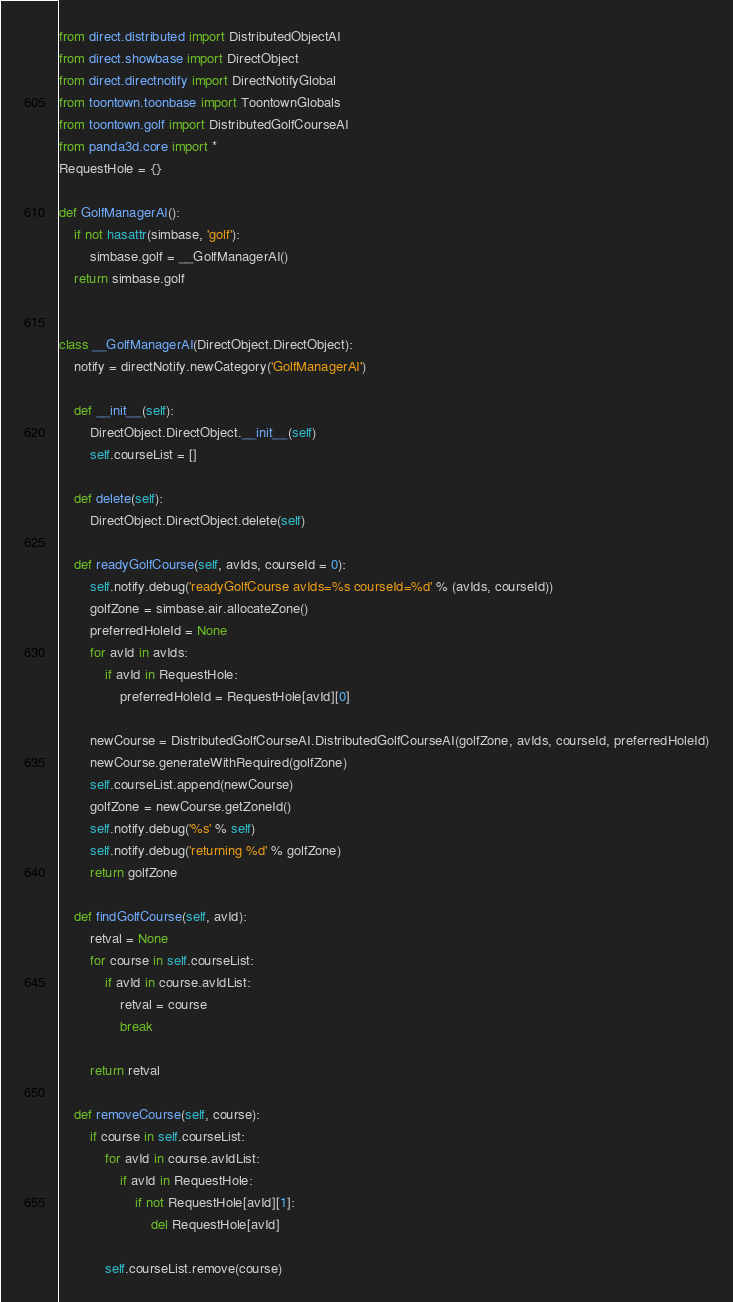Convert code to text. <code><loc_0><loc_0><loc_500><loc_500><_Python_>from direct.distributed import DistributedObjectAI
from direct.showbase import DirectObject
from direct.directnotify import DirectNotifyGlobal
from toontown.toonbase import ToontownGlobals
from toontown.golf import DistributedGolfCourseAI
from panda3d.core import *
RequestHole = {}

def GolfManagerAI():
    if not hasattr(simbase, 'golf'):
        simbase.golf = __GolfManagerAI()
    return simbase.golf


class __GolfManagerAI(DirectObject.DirectObject):
    notify = directNotify.newCategory('GolfManagerAI')

    def __init__(self):
        DirectObject.DirectObject.__init__(self)
        self.courseList = []

    def delete(self):
        DirectObject.DirectObject.delete(self)

    def readyGolfCourse(self, avIds, courseId = 0):
        self.notify.debug('readyGolfCourse avIds=%s courseId=%d' % (avIds, courseId))
        golfZone = simbase.air.allocateZone()
        preferredHoleId = None
        for avId in avIds:
            if avId in RequestHole:
                preferredHoleId = RequestHole[avId][0]

        newCourse = DistributedGolfCourseAI.DistributedGolfCourseAI(golfZone, avIds, courseId, preferredHoleId)
        newCourse.generateWithRequired(golfZone)
        self.courseList.append(newCourse)
        golfZone = newCourse.getZoneId()
        self.notify.debug('%s' % self)
        self.notify.debug('returning %d' % golfZone)
        return golfZone

    def findGolfCourse(self, avId):
        retval = None
        for course in self.courseList:
            if avId in course.avIdList:
                retval = course
                break

        return retval

    def removeCourse(self, course):
        if course in self.courseList:
            for avId in course.avIdList:
                if avId in RequestHole:
                    if not RequestHole[avId][1]:
                        del RequestHole[avId]

            self.courseList.remove(course)
</code> 